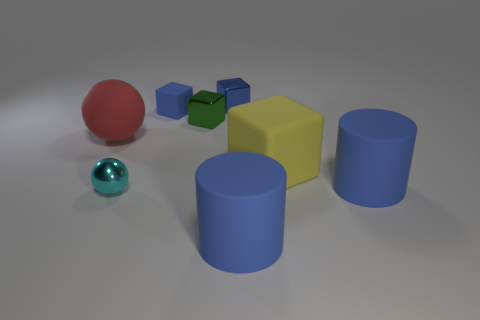Can you tell me more about the red object; does it have any special characteristics compared to the other objects? Certainly! The red object in the image is a sphere with a polished surface, contrasting with the matte textures seen on some of the cubes and one of the cylinders. Its reflective quality captures light and environment, which gives it a unique appearance among the objects. 